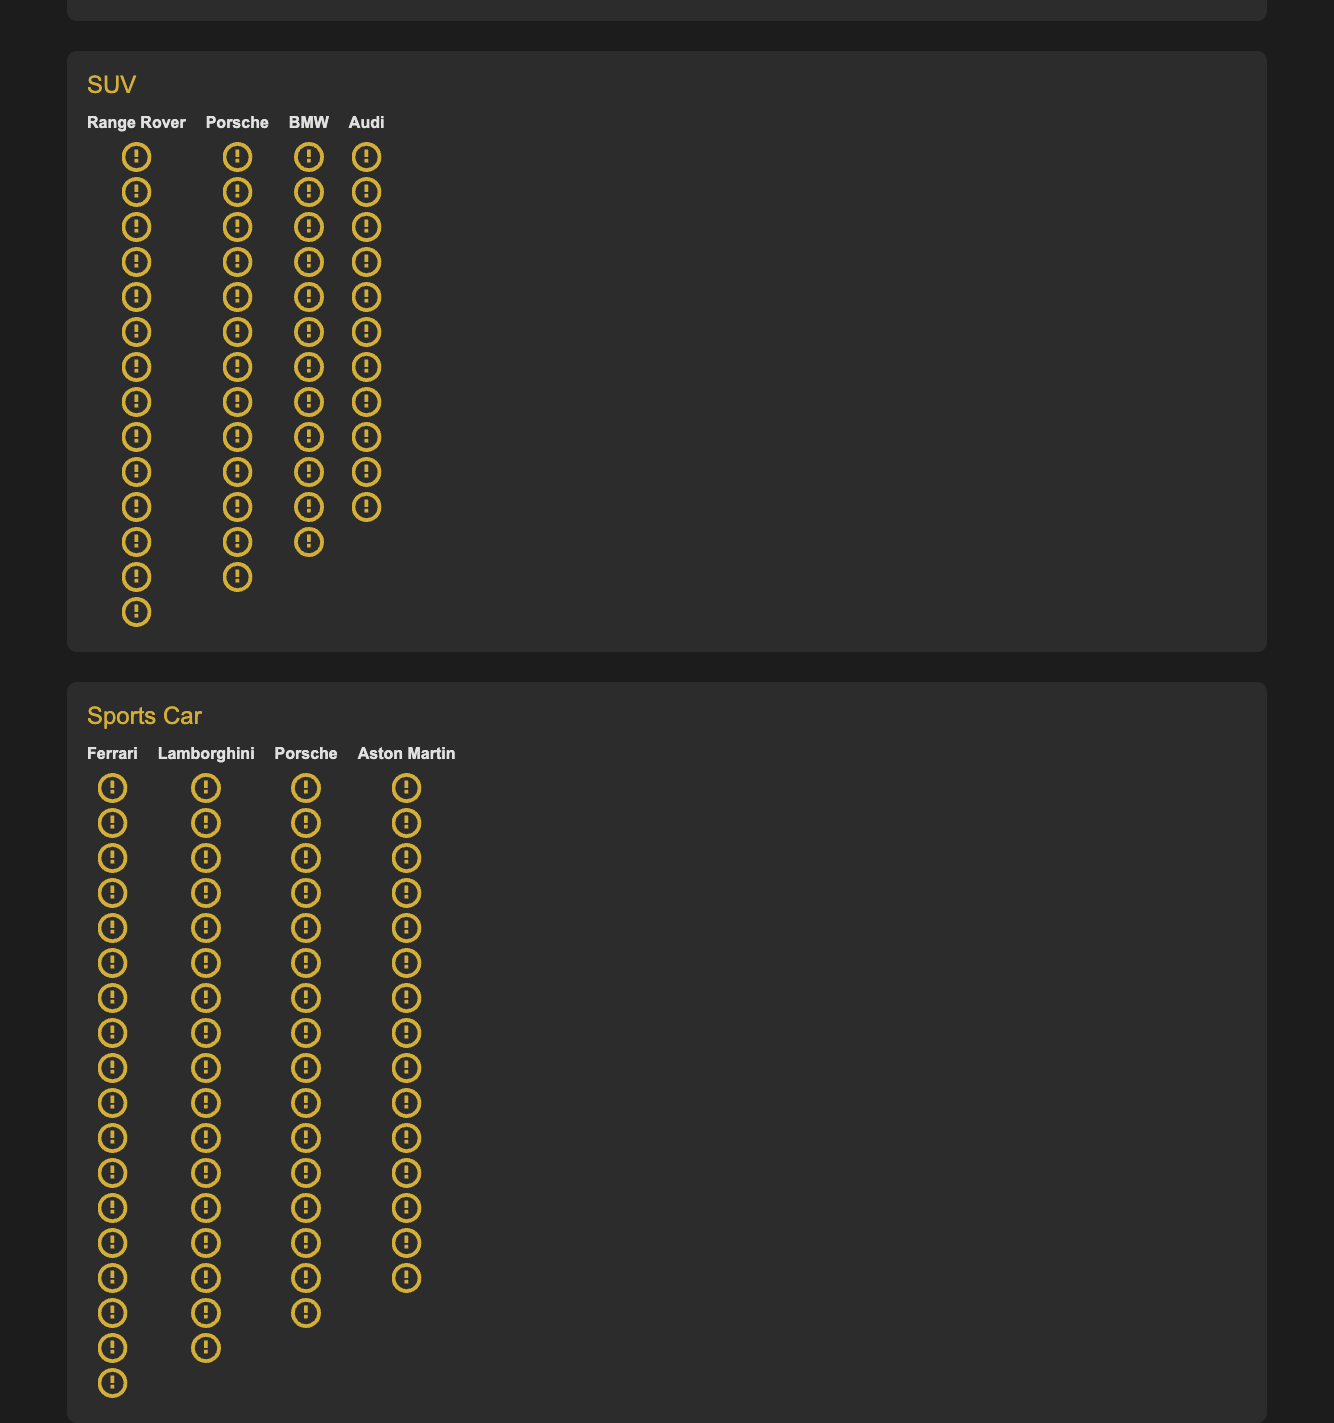What is the highest horsepower for the Sedan category? The Sedan category lists several brands with their respective horsepower values. The highest horsepower listed among them is Mercedes-Benz with 12 horsepower symbols.
Answer: 12 Which brand has the lowest horsepower in the SUV category? In the SUV category, the values are 14, 13, 12, and 11 for Range Rover, Porsche, BMW, and Audi, respectively. The lowest value is for Audi.
Answer: Audi How many more horsepower symbols does Ferrari have compared to Lamborghini? Ferrari has 18 horsepower symbols while Lamborghini has 17 horsepower symbols. The difference between them is 18 - 17.
Answer: 1 Which category features Porsche twice and how many horsepower symbols do they have in total within that category? Porsche appears in both the SUV and Sports Car categories. In the SUV category, Porsche has 13 horsepower symbols, and in the Sports Car category, it has 16.
Answer: SUV, 29 Examine the Sedan category and count the total number of horsepower symbols displayed. The horsepower symbols for the Sedan category are as follows: Mercedes-Benz (12), BMW (11), Audi (10), Lexus (9). The total is 12 + 11 + 10 + 9.
Answer: 42 Who has more horsepower in the Sports Car category, Porsche or Aston Martin? In the Sports Car category, Porsche has 16 horsepower symbols, while Aston Martin has 15 horsepower symbols.
Answer: Porsche What is the average horsepower across all brands in the SUV category? The SUV category has horsepower values of 14, 13, 12, and 11 for Range Rover, Porsche, BMW, and Audi. The average is calculated as (14 + 13 + 12 + 11) / 4.
Answer: 12.5 In the Sedan category, how many fewer horsepower symbols does Lexus have compared to Mercedes-Benz? Lexus has 9 horsepower symbols, and Mercedes-Benz has 12. The difference is 12 - 9.
Answer: 3 Which brand has the maximum horsepower in the Sports Car category? The horsepower values in the Sports Car category are 18 for Ferrari, 17 for Lamborghini, 16 for Porsche, and 15 for Aston Martin. The highest is Ferrari.
Answer: Ferrari Between BMW (Sedan) and BMW (SUV), which has more horsepower symbols? In the Sedan category, BMW has 11 horsepower symbols. In the SUV category, BMW has 12 horsepower symbols.
Answer: BMW (SUV) 